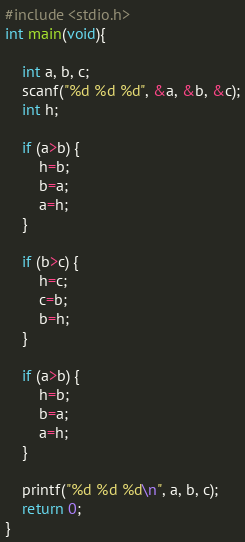<code> <loc_0><loc_0><loc_500><loc_500><_C_>#include <stdio.h>
int main(void){
    
	int a, b, c;
	scanf("%d %d %d", &a, &b, &c);
	int h;
 
	if (a>b) {
		h=b;
		b=a;
		a=h;
	}
	
	if (b>c) {
		h=c;
		c=b;
		b=h;
	}
	
	if (a>b) {
		h=b;
		b=a;
		a=h;
	}
	
	printf("%d %d %d\n", a, b, c);
	return 0;
}
</code> 